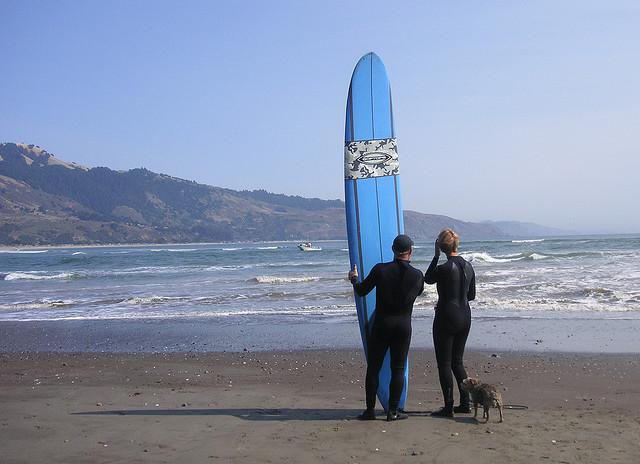Is the dog in front of the people?
Short answer required. No. Which person is holding the surfboard?
Quick response, please. One on left. What is the gender of the two people?
Quick response, please. Male and female. What symbol is on his board?
Be succinct. Peace. Are they in the ocean?
Concise answer only. No. How many surfboards are behind the man?
Answer briefly. 1. Is there a dog?
Be succinct. Yes. 